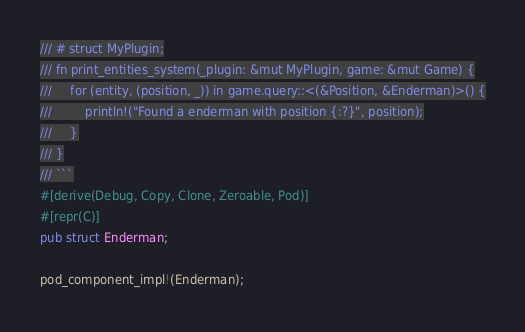Convert code to text. <code><loc_0><loc_0><loc_500><loc_500><_Rust_>/// # struct MyPlugin;
/// fn print_entities_system(_plugin: &mut MyPlugin, game: &mut Game) {
///     for (entity, (position, _)) in game.query::<(&Position, &Enderman)>() {
///         println!("Found a enderman with position {:?}", position);
///     }
/// }
/// ```
#[derive(Debug, Copy, Clone, Zeroable, Pod)]
#[repr(C)]
pub struct Enderman;

pod_component_impl!(Enderman);
</code> 